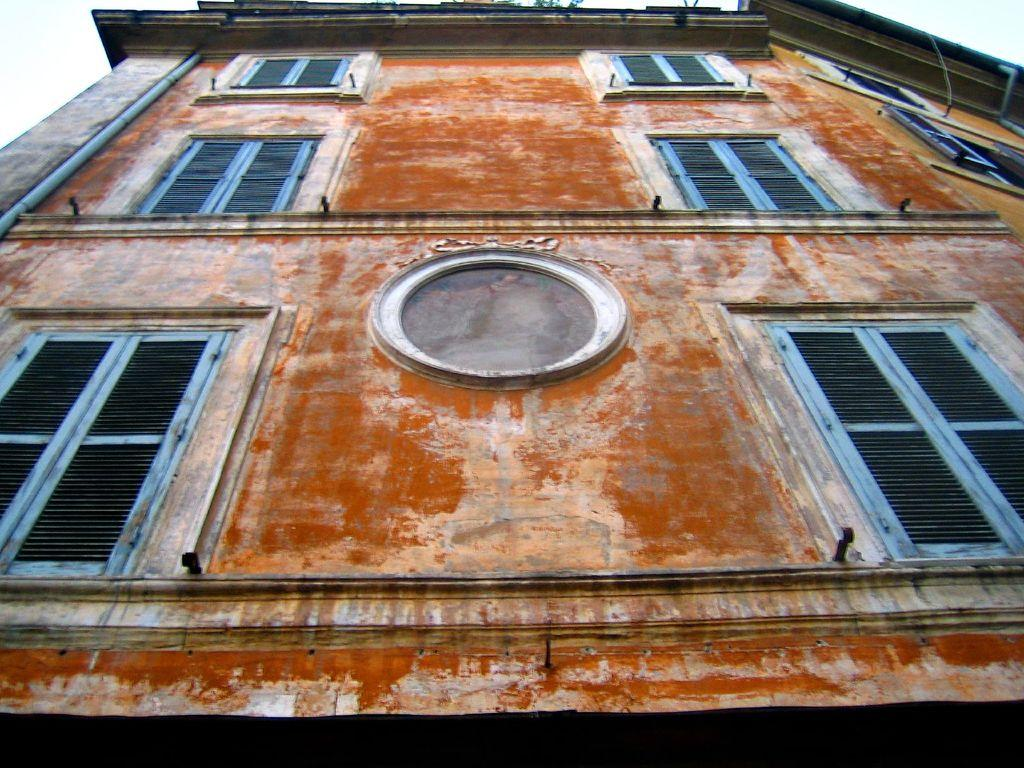What structure is present in the image? There is a building in the image. What feature can be seen on the building? The building has windows. Is there any additional element associated with the building? Yes, there is a pipe associated with the building. What can be seen in the background of the image? The sky is visible in the background of the image. What type of owl is perched on the sweater in the image? There is no owl or sweater present in the image. 